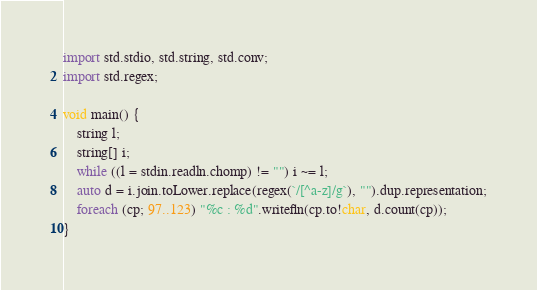<code> <loc_0><loc_0><loc_500><loc_500><_D_>import std.stdio, std.string, std.conv;
import std.regex;

void main() {
	string l;
	string[] i;
	while ((l = stdin.readln.chomp) != "") i ~= l;
	auto d = i.join.toLower.replace(regex(`/[^a-z]/g`), "").dup.representation;
	foreach (cp; 97..123) "%c : %d".writefln(cp.to!char, d.count(cp));
}</code> 